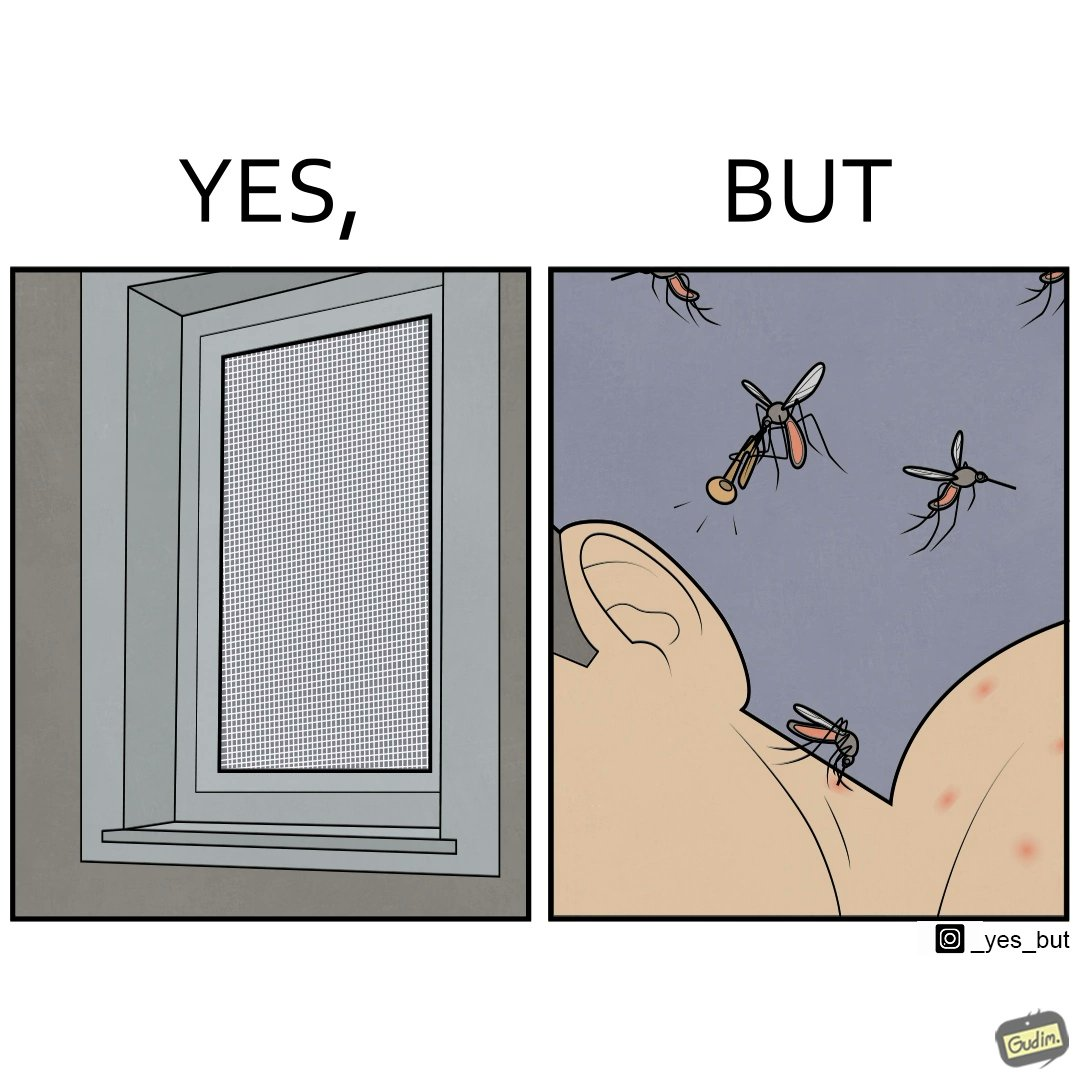Compare the left and right sides of this image. In the left part of the image: It is a window with a mosquito net In the right part of the image: It is a man with many mosquito bites while one out of the many mosquitoes is playing a trumpet into his ear 